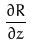Convert formula to latex. <formula><loc_0><loc_0><loc_500><loc_500>\frac { \partial R } { \partial z }</formula> 